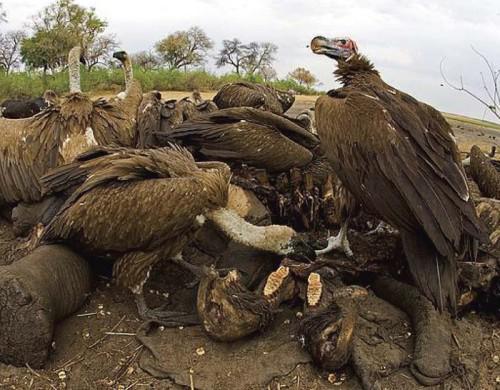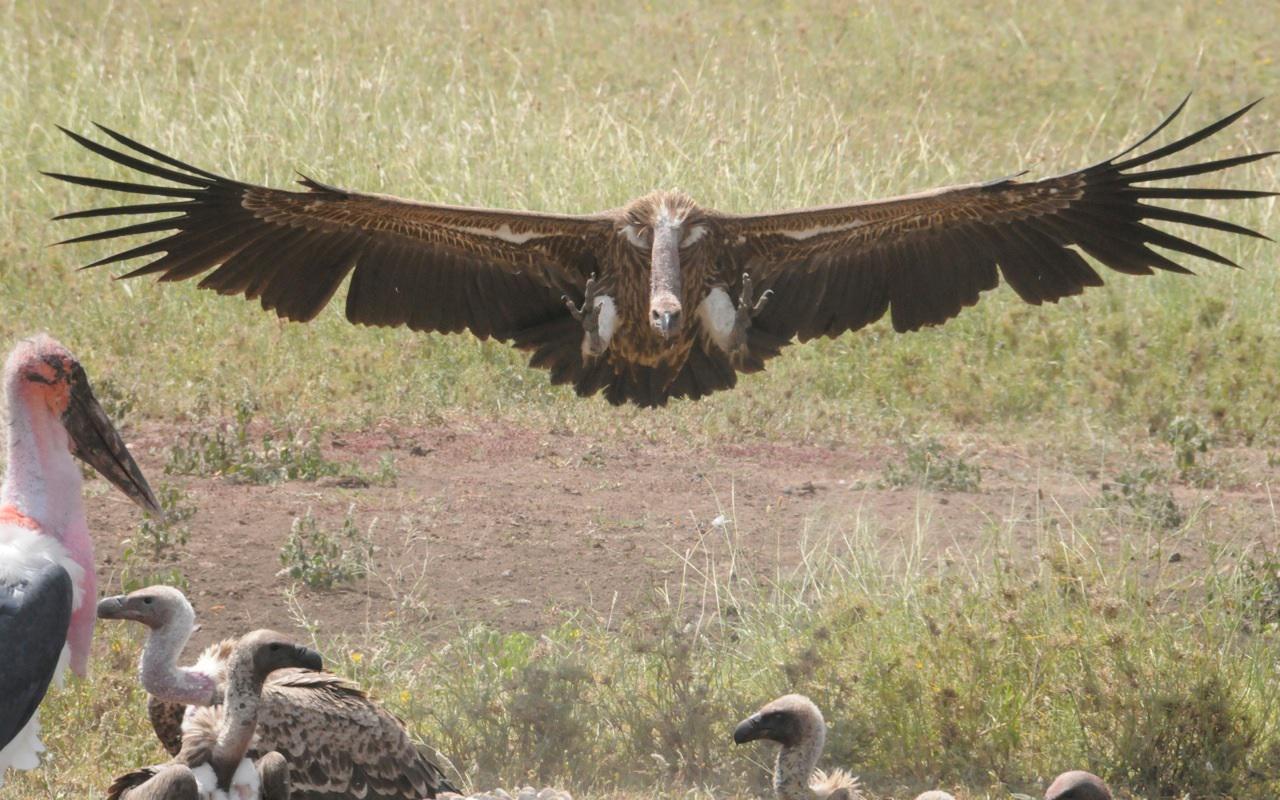The first image is the image on the left, the second image is the image on the right. Assess this claim about the two images: "In the right image, at least one hyena is present along with vultures.". Correct or not? Answer yes or no. No. The first image is the image on the left, the second image is the image on the right. Evaluate the accuracy of this statement regarding the images: "there is a hyena in the image on the right.". Is it true? Answer yes or no. No. 